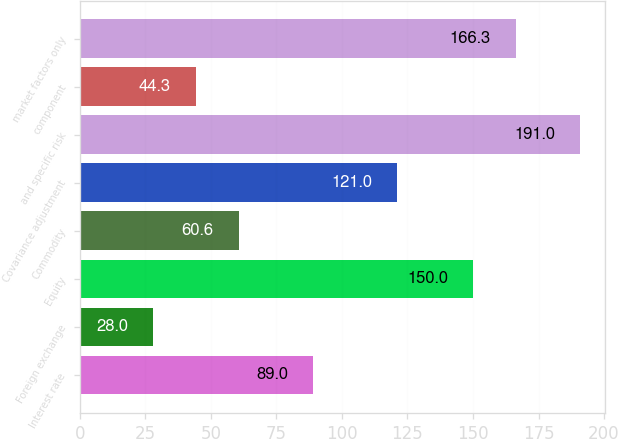<chart> <loc_0><loc_0><loc_500><loc_500><bar_chart><fcel>Interest rate<fcel>Foreign exchange<fcel>Equity<fcel>Commodity<fcel>Covariance adjustment<fcel>and specific risk<fcel>component<fcel>market factors only<nl><fcel>89<fcel>28<fcel>150<fcel>60.6<fcel>121<fcel>191<fcel>44.3<fcel>166.3<nl></chart> 